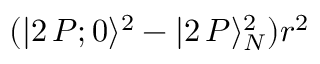Convert formula to latex. <formula><loc_0><loc_0><loc_500><loc_500>( | 2 \, P ; 0 \rangle ^ { 2 } - | 2 \, P \rangle _ { N } ^ { 2 } ) r ^ { 2 }</formula> 